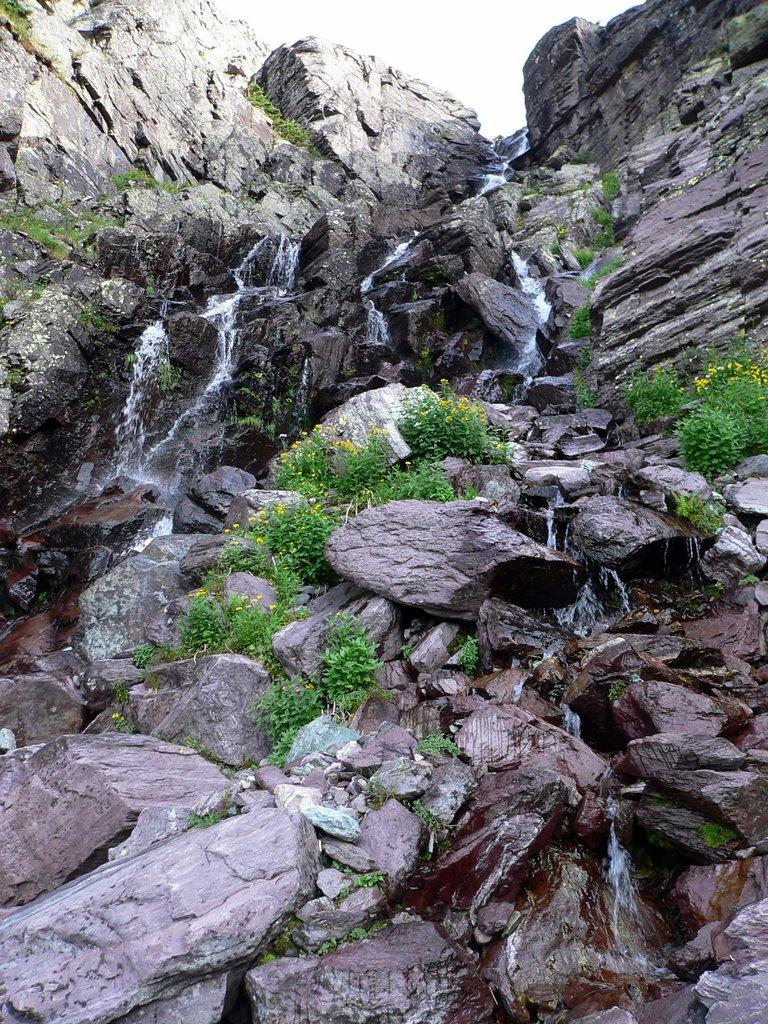What geographical feature is present in the image? There is a hill in the image. What is happening to the water at the top of the hill? Water is falling from the top of the hill. What type of vegetation can be seen in the image? There are plants in the image. What can be seen in the distance in the image? The sky is visible in the background of the image. How many women are riding bikes on the hill in the image? There are no women or bikes present in the image; it features a hill with water falling and plants. Is the hill covered in snow in the image? The image does not indicate that the hill is covered in snow or that it is winter; there is no mention of snow or winter clothing in the provided facts. 